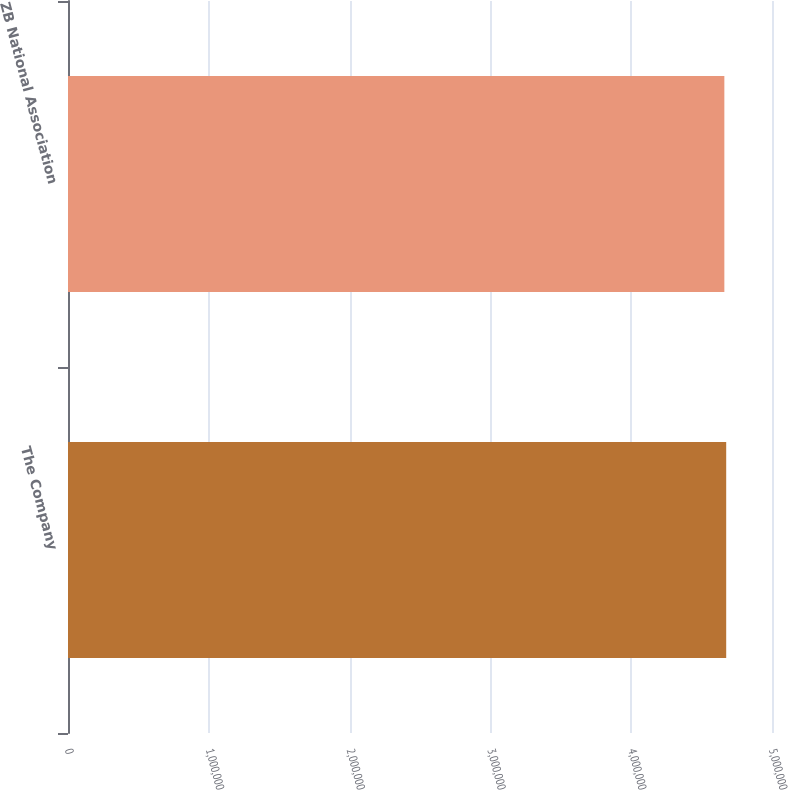Convert chart. <chart><loc_0><loc_0><loc_500><loc_500><bar_chart><fcel>The Company<fcel>ZB National Association<nl><fcel>4.67472e+06<fcel>4.66158e+06<nl></chart> 